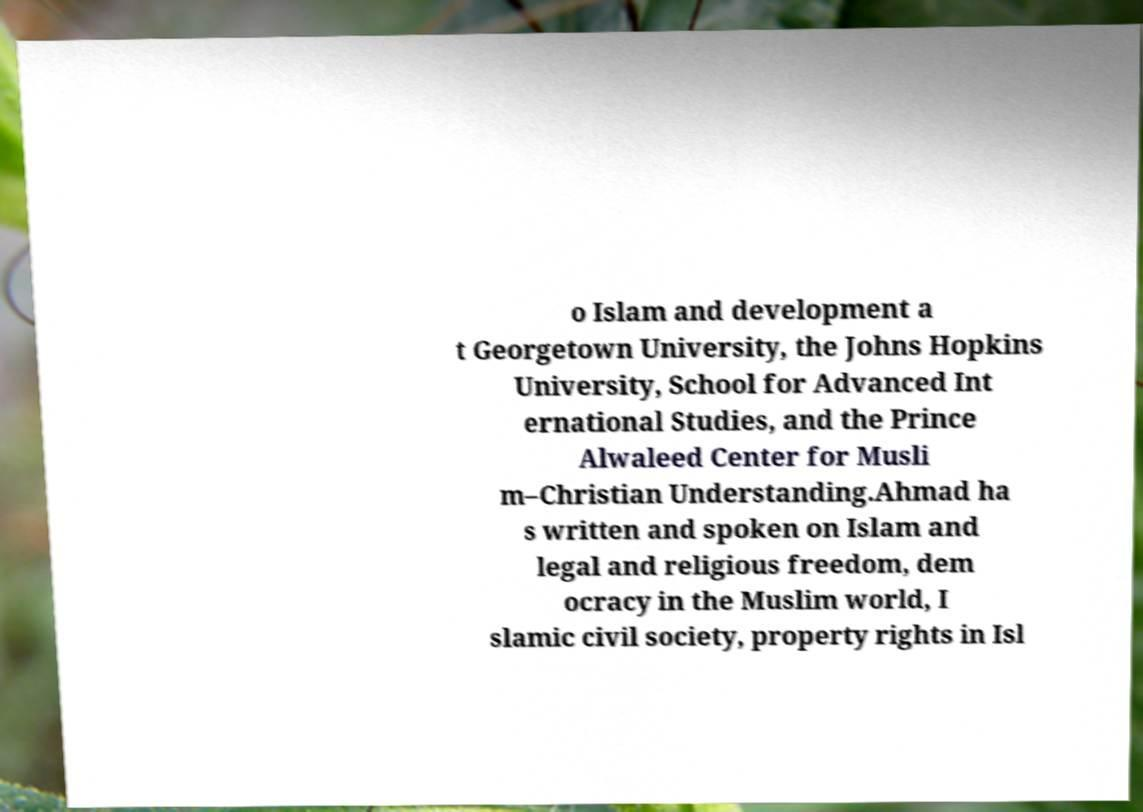Can you accurately transcribe the text from the provided image for me? o Islam and development a t Georgetown University, the Johns Hopkins University, School for Advanced Int ernational Studies, and the Prince Alwaleed Center for Musli m–Christian Understanding.Ahmad ha s written and spoken on Islam and legal and religious freedom, dem ocracy in the Muslim world, I slamic civil society, property rights in Isl 